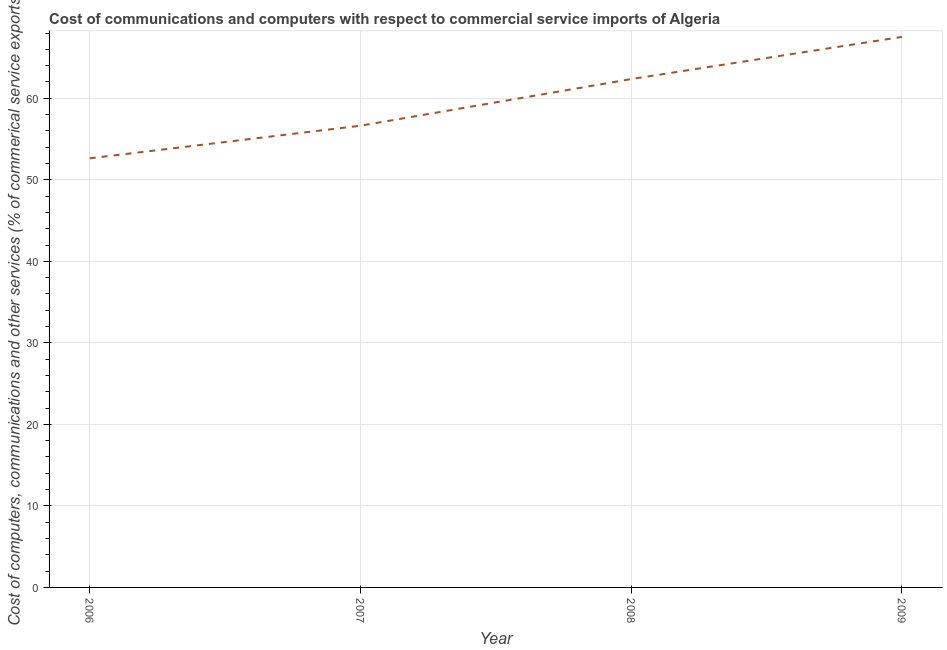What is the cost of communications in 2007?
Your answer should be compact. 56.64. Across all years, what is the maximum cost of communications?
Offer a very short reply. 67.53. Across all years, what is the minimum cost of communications?
Offer a terse response. 52.64. In which year was the cost of communications maximum?
Give a very brief answer. 2009. What is the sum of the cost of communications?
Offer a terse response. 239.16. What is the difference between the cost of communications in 2007 and 2008?
Provide a short and direct response. -5.72. What is the average  computer and other services per year?
Make the answer very short. 59.79. What is the median  computer and other services?
Provide a short and direct response. 59.5. What is the ratio of the  computer and other services in 2006 to that in 2007?
Offer a very short reply. 0.93. Is the cost of communications in 2006 less than that in 2008?
Ensure brevity in your answer.  Yes. What is the difference between the highest and the second highest  computer and other services?
Ensure brevity in your answer.  5.17. Is the sum of the  computer and other services in 2007 and 2009 greater than the maximum  computer and other services across all years?
Provide a short and direct response. Yes. What is the difference between the highest and the lowest  computer and other services?
Ensure brevity in your answer.  14.89. In how many years, is the  computer and other services greater than the average  computer and other services taken over all years?
Provide a short and direct response. 2. Are the values on the major ticks of Y-axis written in scientific E-notation?
Provide a succinct answer. No. Does the graph contain grids?
Keep it short and to the point. Yes. What is the title of the graph?
Keep it short and to the point. Cost of communications and computers with respect to commercial service imports of Algeria. What is the label or title of the Y-axis?
Give a very brief answer. Cost of computers, communications and other services (% of commerical service exports). What is the Cost of computers, communications and other services (% of commerical service exports) of 2006?
Your response must be concise. 52.64. What is the Cost of computers, communications and other services (% of commerical service exports) of 2007?
Provide a succinct answer. 56.64. What is the Cost of computers, communications and other services (% of commerical service exports) in 2008?
Provide a succinct answer. 62.36. What is the Cost of computers, communications and other services (% of commerical service exports) in 2009?
Your answer should be compact. 67.53. What is the difference between the Cost of computers, communications and other services (% of commerical service exports) in 2006 and 2007?
Keep it short and to the point. -4. What is the difference between the Cost of computers, communications and other services (% of commerical service exports) in 2006 and 2008?
Provide a succinct answer. -9.72. What is the difference between the Cost of computers, communications and other services (% of commerical service exports) in 2006 and 2009?
Give a very brief answer. -14.89. What is the difference between the Cost of computers, communications and other services (% of commerical service exports) in 2007 and 2008?
Offer a very short reply. -5.72. What is the difference between the Cost of computers, communications and other services (% of commerical service exports) in 2007 and 2009?
Offer a very short reply. -10.89. What is the difference between the Cost of computers, communications and other services (% of commerical service exports) in 2008 and 2009?
Provide a succinct answer. -5.17. What is the ratio of the Cost of computers, communications and other services (% of commerical service exports) in 2006 to that in 2007?
Your response must be concise. 0.93. What is the ratio of the Cost of computers, communications and other services (% of commerical service exports) in 2006 to that in 2008?
Provide a short and direct response. 0.84. What is the ratio of the Cost of computers, communications and other services (% of commerical service exports) in 2006 to that in 2009?
Your answer should be compact. 0.78. What is the ratio of the Cost of computers, communications and other services (% of commerical service exports) in 2007 to that in 2008?
Make the answer very short. 0.91. What is the ratio of the Cost of computers, communications and other services (% of commerical service exports) in 2007 to that in 2009?
Give a very brief answer. 0.84. What is the ratio of the Cost of computers, communications and other services (% of commerical service exports) in 2008 to that in 2009?
Offer a terse response. 0.92. 